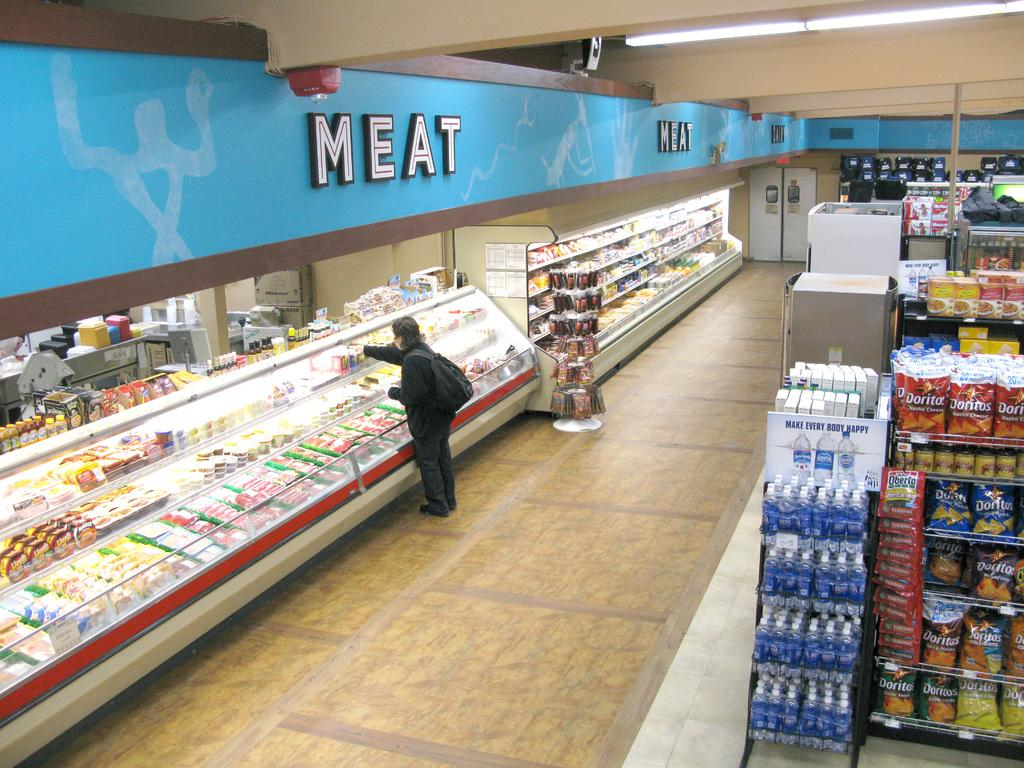<image>
Share a concise interpretation of the image provided. A person standing at a grocery counter under a large sign reading MEAT. 